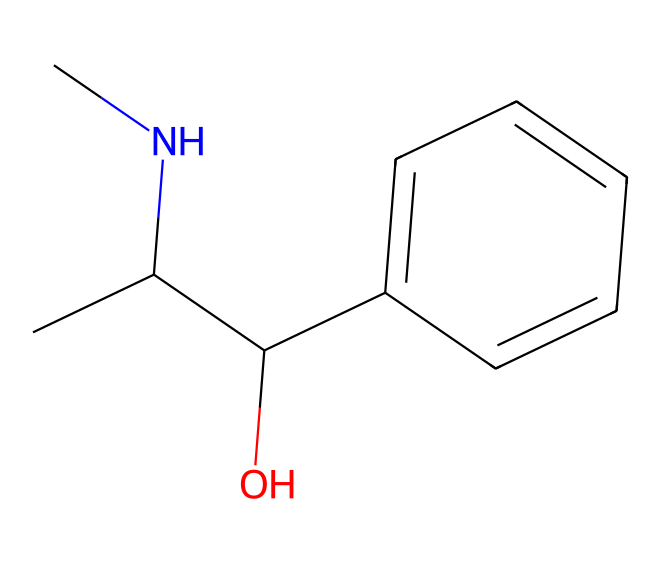What is the molecular formula of ephedrine? By analyzing the SMILES representation, we can count the number of each type of atom present. In the structure, we see 10 carbon atoms (C), 15 hydrogen atoms (H), and 1 nitrogen atom (N) and 1 oxygen atom (O). Thus, the molecular formula is C10H15NO.
Answer: C10H15NO How many rings are present in the structure of ephedrine? Looking at the SMILES notation, there are no cyclic components explicitly shown. The benzene-like part is represented by 'c1ccccc1,' which indicates a single aromatic ring. Therefore, there is one ring present in the structure.
Answer: 1 What type of functional group is present in ephedrine? The SMILES structure shows 'C(O)', indicating the presence of a hydroxyl group (-OH), which is a characteristic functional group found in alcohols. The compound is also a secondary amine due to the presence of the nitrogen atom attached to two carbon atoms.
Answer: hydroxyl group What is the role of nitrogen in ephedrine? The nitrogen in the structure contributes to the basic nature of ephedrine. Typically, the presence of nitrogen in alkaloids like ephedrine can also be associated with their physiological effects, including acting as sympathomimetics which help relieve nasal congestion.
Answer: basic nature How does the structure of ephedrine relate to its classification as an alkaloid? Alkaloids are a class of naturally occurring compounds that mostly contain basic nitrogen atoms. The presence of a nitrogen atom in ephedrine’s structure, along with its biological activity, qualifies it as an alkaloid.
Answer: nitrogen atom What is the significance of the hydroxyl group in ephedrine? The hydroxyl group (-OH) in ephedrine increases its solubility in water, enhancing its pharmacological properties and the ability of the drug to be absorbed in the body. This functional group is essential for its interaction with biological systems.
Answer: increases solubility 